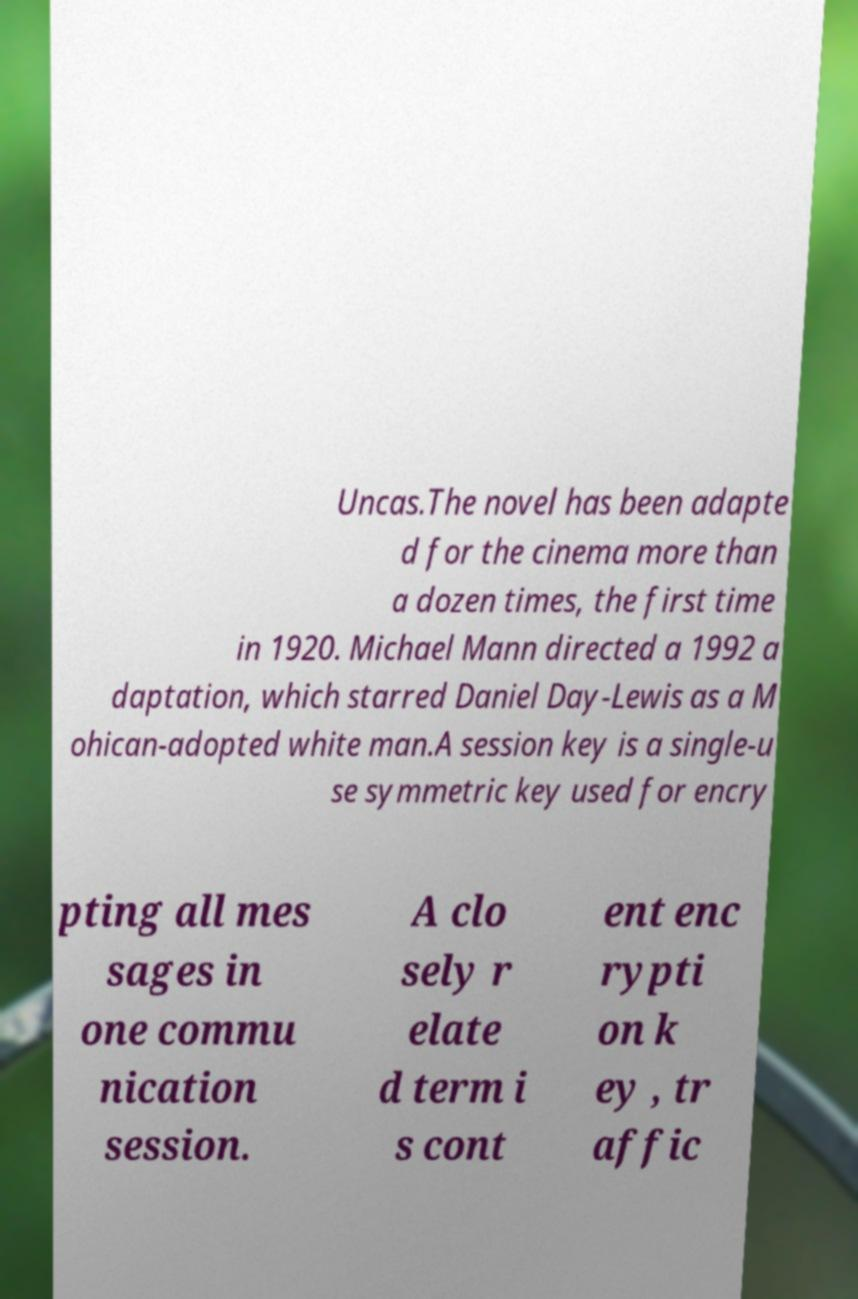I need the written content from this picture converted into text. Can you do that? Uncas.The novel has been adapte d for the cinema more than a dozen times, the first time in 1920. Michael Mann directed a 1992 a daptation, which starred Daniel Day-Lewis as a M ohican-adopted white man.A session key is a single-u se symmetric key used for encry pting all mes sages in one commu nication session. A clo sely r elate d term i s cont ent enc rypti on k ey , tr affic 